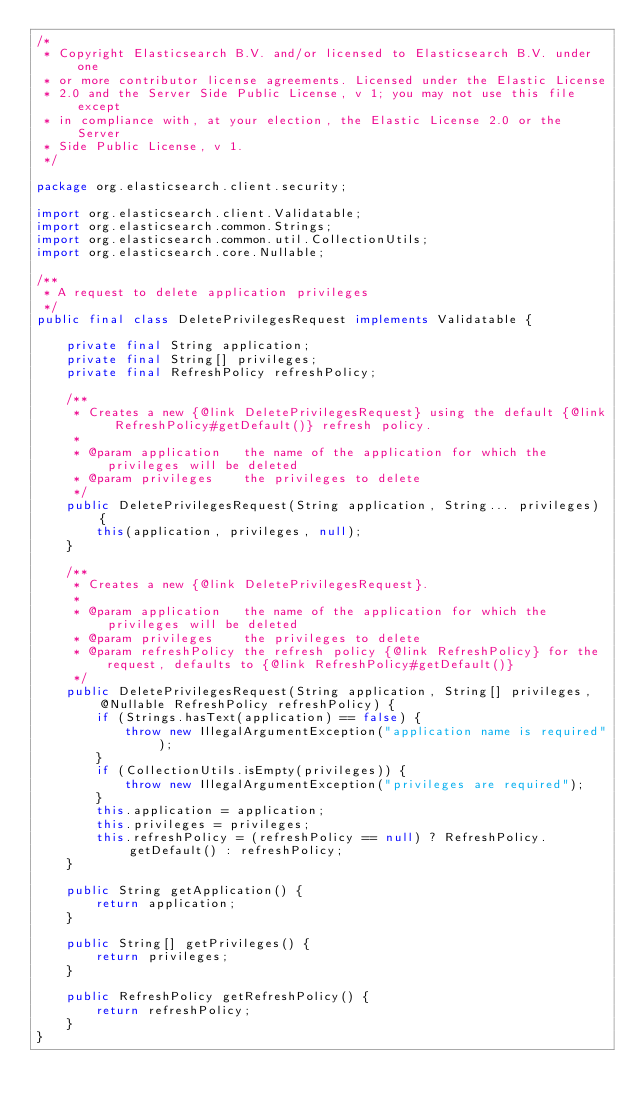<code> <loc_0><loc_0><loc_500><loc_500><_Java_>/*
 * Copyright Elasticsearch B.V. and/or licensed to Elasticsearch B.V. under one
 * or more contributor license agreements. Licensed under the Elastic License
 * 2.0 and the Server Side Public License, v 1; you may not use this file except
 * in compliance with, at your election, the Elastic License 2.0 or the Server
 * Side Public License, v 1.
 */

package org.elasticsearch.client.security;

import org.elasticsearch.client.Validatable;
import org.elasticsearch.common.Strings;
import org.elasticsearch.common.util.CollectionUtils;
import org.elasticsearch.core.Nullable;

/**
 * A request to delete application privileges
 */
public final class DeletePrivilegesRequest implements Validatable {

    private final String application;
    private final String[] privileges;
    private final RefreshPolicy refreshPolicy;

    /**
     * Creates a new {@link DeletePrivilegesRequest} using the default {@link RefreshPolicy#getDefault()} refresh policy.
     *
     * @param application   the name of the application for which the privileges will be deleted
     * @param privileges    the privileges to delete
     */
    public DeletePrivilegesRequest(String application, String... privileges) {
        this(application, privileges, null);
    }

    /**
     * Creates a new {@link DeletePrivilegesRequest}.
     *
     * @param application   the name of the application for which the privileges will be deleted
     * @param privileges    the privileges to delete
     * @param refreshPolicy the refresh policy {@link RefreshPolicy} for the request, defaults to {@link RefreshPolicy#getDefault()}
     */
    public DeletePrivilegesRequest(String application, String[] privileges, @Nullable RefreshPolicy refreshPolicy) {
        if (Strings.hasText(application) == false) {
            throw new IllegalArgumentException("application name is required");
        }
        if (CollectionUtils.isEmpty(privileges)) {
            throw new IllegalArgumentException("privileges are required");
        }
        this.application = application;
        this.privileges = privileges;
        this.refreshPolicy = (refreshPolicy == null) ? RefreshPolicy.getDefault() : refreshPolicy;
    }

    public String getApplication() {
        return application;
    }

    public String[] getPrivileges() {
        return privileges;
    }

    public RefreshPolicy getRefreshPolicy() {
        return refreshPolicy;
    }
}
</code> 